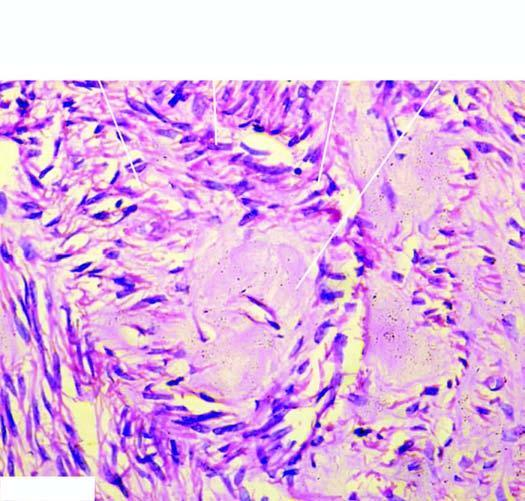what show pink homogeneous hyaline material connective tissue hyaline?
Answer the question using a single word or phrase. The centres of whorls of smooth muscle 